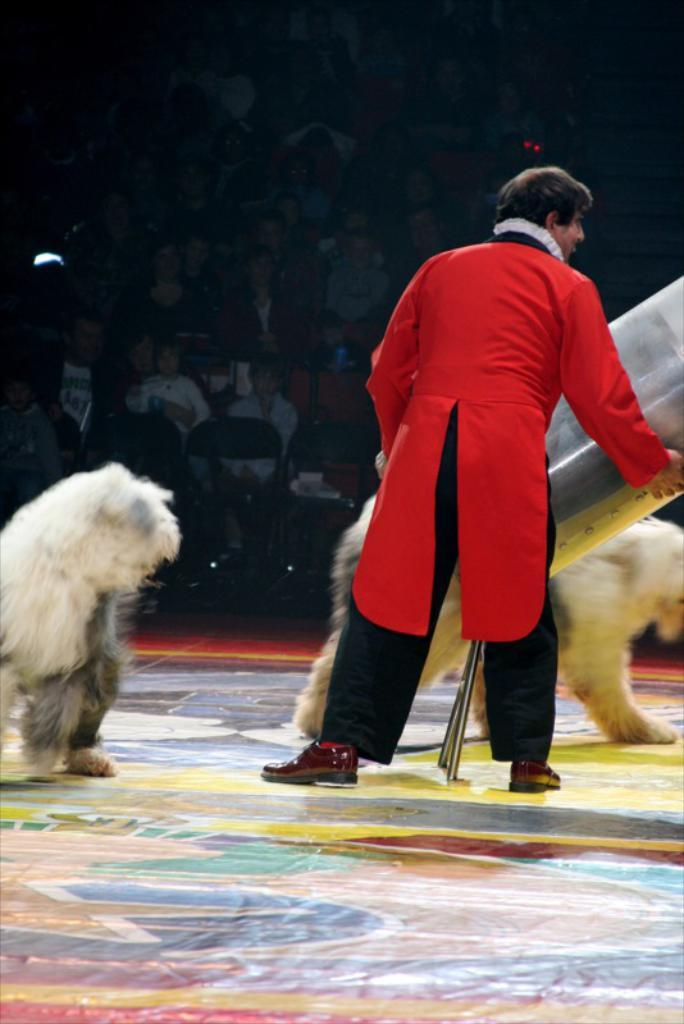How many animals are in the image? There are two animals in the image. What else can be seen in the image besides the animals? There is a person and people sitting on chairs in the image. Can you describe the person in the image? There is a person wearing a red shirt in the image. What type of instrument is the person playing in the image? There is no instrument present in the image; the person is not playing any instrument. 